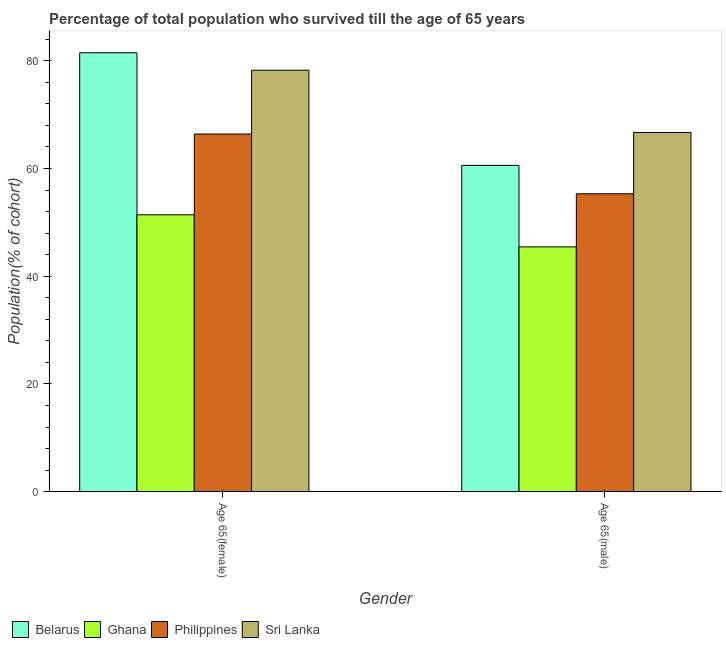How many groups of bars are there?
Give a very brief answer. 2. How many bars are there on the 2nd tick from the right?
Your answer should be compact. 4. What is the label of the 2nd group of bars from the left?
Keep it short and to the point. Age 65(male). What is the percentage of female population who survived till age of 65 in Belarus?
Provide a short and direct response. 81.49. Across all countries, what is the maximum percentage of male population who survived till age of 65?
Offer a terse response. 66.69. Across all countries, what is the minimum percentage of male population who survived till age of 65?
Give a very brief answer. 45.45. In which country was the percentage of female population who survived till age of 65 maximum?
Offer a terse response. Belarus. What is the total percentage of female population who survived till age of 65 in the graph?
Provide a succinct answer. 277.54. What is the difference between the percentage of male population who survived till age of 65 in Sri Lanka and that in Belarus?
Offer a terse response. 6.11. What is the difference between the percentage of male population who survived till age of 65 in Philippines and the percentage of female population who survived till age of 65 in Ghana?
Your answer should be compact. 3.9. What is the average percentage of male population who survived till age of 65 per country?
Offer a very short reply. 57.01. What is the difference between the percentage of male population who survived till age of 65 and percentage of female population who survived till age of 65 in Ghana?
Provide a short and direct response. -5.96. What is the ratio of the percentage of female population who survived till age of 65 in Sri Lanka to that in Belarus?
Your response must be concise. 0.96. What does the 4th bar from the left in Age 65(female) represents?
Keep it short and to the point. Sri Lanka. What does the 1st bar from the right in Age 65(female) represents?
Provide a short and direct response. Sri Lanka. How many bars are there?
Keep it short and to the point. 8. How many countries are there in the graph?
Provide a short and direct response. 4. Are the values on the major ticks of Y-axis written in scientific E-notation?
Offer a very short reply. No. Does the graph contain grids?
Offer a very short reply. No. Where does the legend appear in the graph?
Give a very brief answer. Bottom left. What is the title of the graph?
Provide a short and direct response. Percentage of total population who survived till the age of 65 years. Does "Aruba" appear as one of the legend labels in the graph?
Your answer should be compact. No. What is the label or title of the Y-axis?
Your response must be concise. Population(% of cohort). What is the Population(% of cohort) in Belarus in Age 65(female)?
Ensure brevity in your answer.  81.49. What is the Population(% of cohort) in Ghana in Age 65(female)?
Make the answer very short. 51.41. What is the Population(% of cohort) in Philippines in Age 65(female)?
Your response must be concise. 66.4. What is the Population(% of cohort) of Sri Lanka in Age 65(female)?
Your answer should be compact. 78.24. What is the Population(% of cohort) of Belarus in Age 65(male)?
Offer a terse response. 60.58. What is the Population(% of cohort) of Ghana in Age 65(male)?
Offer a very short reply. 45.45. What is the Population(% of cohort) of Philippines in Age 65(male)?
Provide a short and direct response. 55.31. What is the Population(% of cohort) in Sri Lanka in Age 65(male)?
Your answer should be very brief. 66.69. Across all Gender, what is the maximum Population(% of cohort) of Belarus?
Your answer should be compact. 81.49. Across all Gender, what is the maximum Population(% of cohort) of Ghana?
Offer a terse response. 51.41. Across all Gender, what is the maximum Population(% of cohort) of Philippines?
Keep it short and to the point. 66.4. Across all Gender, what is the maximum Population(% of cohort) in Sri Lanka?
Ensure brevity in your answer.  78.24. Across all Gender, what is the minimum Population(% of cohort) of Belarus?
Offer a very short reply. 60.58. Across all Gender, what is the minimum Population(% of cohort) of Ghana?
Provide a short and direct response. 45.45. Across all Gender, what is the minimum Population(% of cohort) in Philippines?
Keep it short and to the point. 55.31. Across all Gender, what is the minimum Population(% of cohort) in Sri Lanka?
Your answer should be very brief. 66.69. What is the total Population(% of cohort) in Belarus in the graph?
Ensure brevity in your answer.  142.07. What is the total Population(% of cohort) of Ghana in the graph?
Offer a very short reply. 96.86. What is the total Population(% of cohort) in Philippines in the graph?
Your answer should be very brief. 121.71. What is the total Population(% of cohort) in Sri Lanka in the graph?
Make the answer very short. 144.93. What is the difference between the Population(% of cohort) in Belarus in Age 65(female) and that in Age 65(male)?
Ensure brevity in your answer.  20.91. What is the difference between the Population(% of cohort) of Ghana in Age 65(female) and that in Age 65(male)?
Offer a terse response. 5.96. What is the difference between the Population(% of cohort) of Philippines in Age 65(female) and that in Age 65(male)?
Offer a terse response. 11.09. What is the difference between the Population(% of cohort) in Sri Lanka in Age 65(female) and that in Age 65(male)?
Make the answer very short. 11.55. What is the difference between the Population(% of cohort) of Belarus in Age 65(female) and the Population(% of cohort) of Ghana in Age 65(male)?
Offer a very short reply. 36.04. What is the difference between the Population(% of cohort) of Belarus in Age 65(female) and the Population(% of cohort) of Philippines in Age 65(male)?
Offer a very short reply. 26.18. What is the difference between the Population(% of cohort) of Belarus in Age 65(female) and the Population(% of cohort) of Sri Lanka in Age 65(male)?
Offer a terse response. 14.8. What is the difference between the Population(% of cohort) in Ghana in Age 65(female) and the Population(% of cohort) in Philippines in Age 65(male)?
Make the answer very short. -3.9. What is the difference between the Population(% of cohort) in Ghana in Age 65(female) and the Population(% of cohort) in Sri Lanka in Age 65(male)?
Your response must be concise. -15.28. What is the difference between the Population(% of cohort) in Philippines in Age 65(female) and the Population(% of cohort) in Sri Lanka in Age 65(male)?
Offer a terse response. -0.29. What is the average Population(% of cohort) of Belarus per Gender?
Your response must be concise. 71.03. What is the average Population(% of cohort) of Ghana per Gender?
Your response must be concise. 48.43. What is the average Population(% of cohort) of Philippines per Gender?
Your answer should be compact. 60.85. What is the average Population(% of cohort) of Sri Lanka per Gender?
Your response must be concise. 72.47. What is the difference between the Population(% of cohort) of Belarus and Population(% of cohort) of Ghana in Age 65(female)?
Make the answer very short. 30.08. What is the difference between the Population(% of cohort) in Belarus and Population(% of cohort) in Philippines in Age 65(female)?
Give a very brief answer. 15.09. What is the difference between the Population(% of cohort) in Belarus and Population(% of cohort) in Sri Lanka in Age 65(female)?
Offer a terse response. 3.24. What is the difference between the Population(% of cohort) in Ghana and Population(% of cohort) in Philippines in Age 65(female)?
Offer a very short reply. -15. What is the difference between the Population(% of cohort) of Ghana and Population(% of cohort) of Sri Lanka in Age 65(female)?
Your response must be concise. -26.84. What is the difference between the Population(% of cohort) of Philippines and Population(% of cohort) of Sri Lanka in Age 65(female)?
Give a very brief answer. -11.84. What is the difference between the Population(% of cohort) in Belarus and Population(% of cohort) in Ghana in Age 65(male)?
Your response must be concise. 15.13. What is the difference between the Population(% of cohort) of Belarus and Population(% of cohort) of Philippines in Age 65(male)?
Your answer should be very brief. 5.27. What is the difference between the Population(% of cohort) of Belarus and Population(% of cohort) of Sri Lanka in Age 65(male)?
Give a very brief answer. -6.11. What is the difference between the Population(% of cohort) in Ghana and Population(% of cohort) in Philippines in Age 65(male)?
Make the answer very short. -9.86. What is the difference between the Population(% of cohort) of Ghana and Population(% of cohort) of Sri Lanka in Age 65(male)?
Offer a terse response. -21.24. What is the difference between the Population(% of cohort) in Philippines and Population(% of cohort) in Sri Lanka in Age 65(male)?
Your answer should be compact. -11.38. What is the ratio of the Population(% of cohort) of Belarus in Age 65(female) to that in Age 65(male)?
Your response must be concise. 1.35. What is the ratio of the Population(% of cohort) in Ghana in Age 65(female) to that in Age 65(male)?
Your answer should be very brief. 1.13. What is the ratio of the Population(% of cohort) in Philippines in Age 65(female) to that in Age 65(male)?
Give a very brief answer. 1.2. What is the ratio of the Population(% of cohort) of Sri Lanka in Age 65(female) to that in Age 65(male)?
Provide a succinct answer. 1.17. What is the difference between the highest and the second highest Population(% of cohort) of Belarus?
Provide a short and direct response. 20.91. What is the difference between the highest and the second highest Population(% of cohort) of Ghana?
Provide a short and direct response. 5.96. What is the difference between the highest and the second highest Population(% of cohort) of Philippines?
Ensure brevity in your answer.  11.09. What is the difference between the highest and the second highest Population(% of cohort) of Sri Lanka?
Provide a succinct answer. 11.55. What is the difference between the highest and the lowest Population(% of cohort) of Belarus?
Your answer should be compact. 20.91. What is the difference between the highest and the lowest Population(% of cohort) in Ghana?
Offer a terse response. 5.96. What is the difference between the highest and the lowest Population(% of cohort) of Philippines?
Your answer should be very brief. 11.09. What is the difference between the highest and the lowest Population(% of cohort) in Sri Lanka?
Offer a terse response. 11.55. 